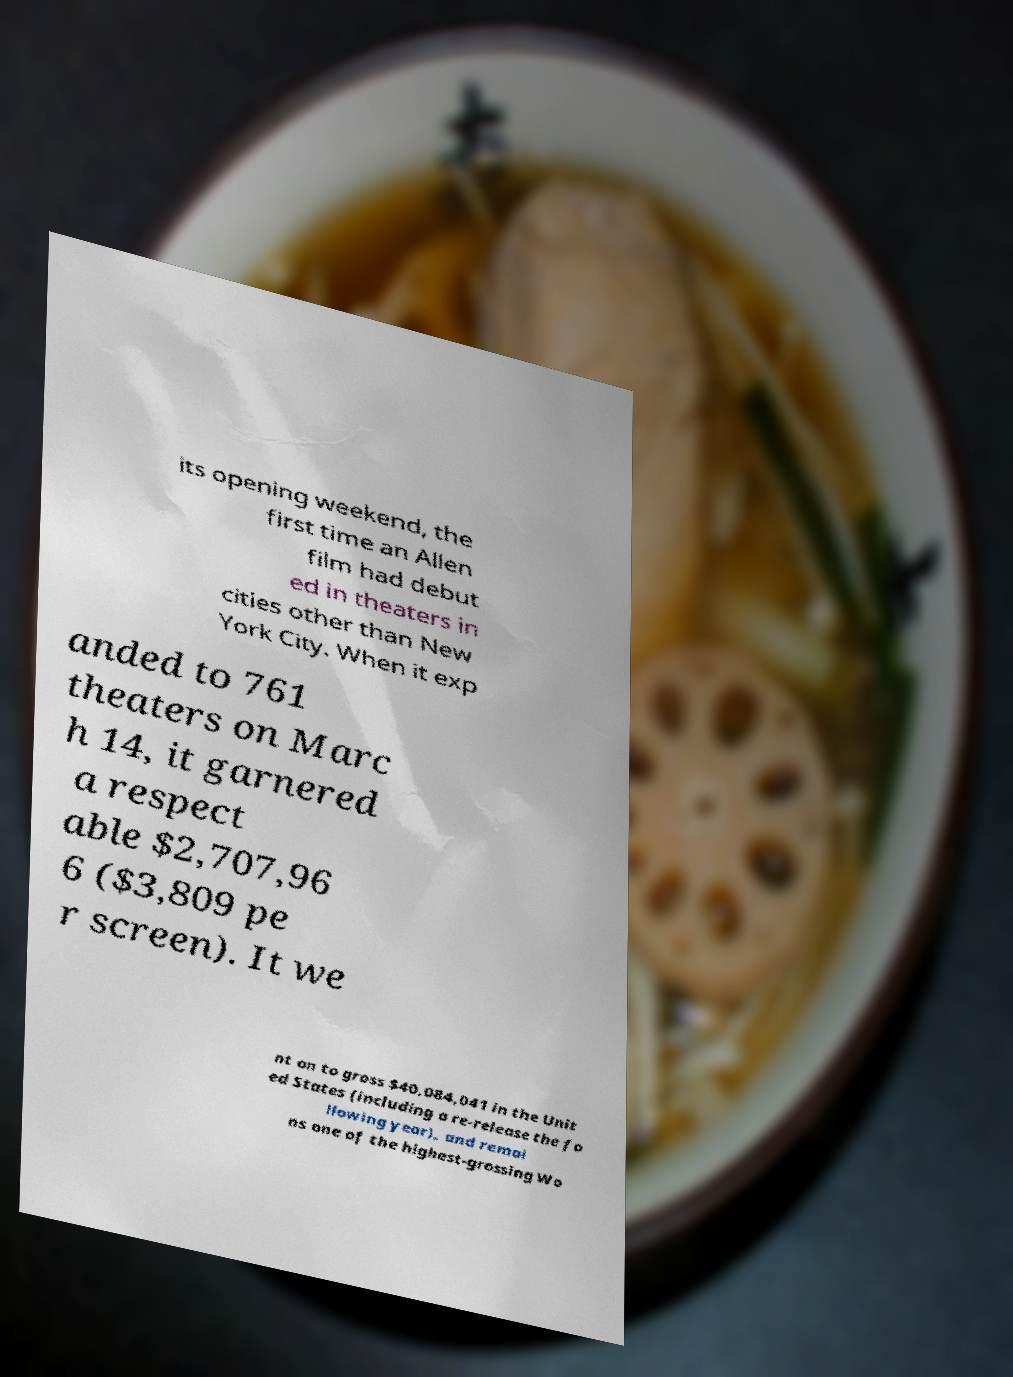Can you read and provide the text displayed in the image?This photo seems to have some interesting text. Can you extract and type it out for me? its opening weekend, the first time an Allen film had debut ed in theaters in cities other than New York City. When it exp anded to 761 theaters on Marc h 14, it garnered a respect able $2,707,96 6 ($3,809 pe r screen). It we nt on to gross $40,084,041 in the Unit ed States (including a re-release the fo llowing year), and remai ns one of the highest-grossing Wo 